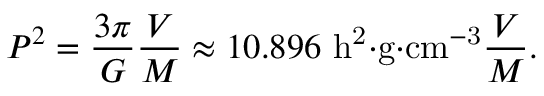Convert formula to latex. <formula><loc_0><loc_0><loc_500><loc_500>P ^ { 2 } = { \frac { 3 \pi } { G } } { \frac { V } { M } } \approx 1 0 . 8 9 6 \ h ^ { 2 } { \cdot } g { \cdot } c m ^ { - 3 } { \frac { V } { M } } .</formula> 